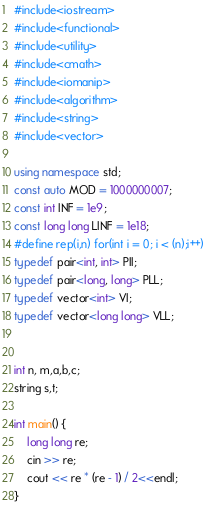<code> <loc_0><loc_0><loc_500><loc_500><_C++_>#include<iostream>
#include<functional>
#include<utility>
#include<cmath>
#include<iomanip>
#include<algorithm>
#include<string>
#include<vector>

using namespace std;
const auto MOD = 1000000007;
const int INF = 1e9;
const long long LINF = 1e18;
#define rep(i,n) for(int i = 0; i < (n);i++)
typedef pair<int, int> PII;
typedef pair<long, long> PLL;
typedef vector<int> VI;
typedef vector<long long> VLL;


int n, m,a,b,c;
string s,t;

int main() {
	long long re;
	cin >> re;
	cout << re * (re - 1) / 2<<endl;
}
</code> 